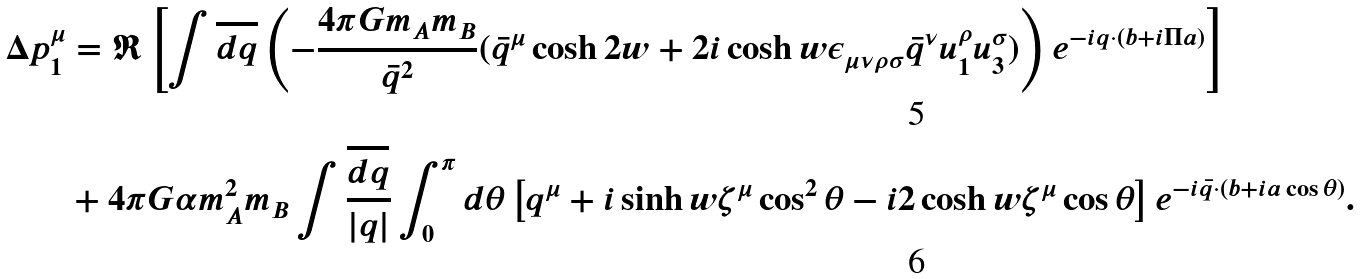<formula> <loc_0><loc_0><loc_500><loc_500>\Delta p ^ { \mu } _ { 1 } & = \Re \left [ \int \overline { d q } \left ( - \frac { 4 \pi G m _ { A } m _ { B } } { \bar { q } ^ { 2 } } ( \bar { q } ^ { \mu } \cosh 2 w + 2 i \cosh w \epsilon _ { \mu \nu \rho \sigma } \bar { q } ^ { \nu } u _ { 1 } ^ { \rho } u _ { 3 } ^ { \sigma } ) \right ) e ^ { - i q \cdot ( b + i \Pi a ) } \right ] \\ & + 4 \pi G \alpha m _ { A } ^ { 2 } m _ { B } \int \frac { \overline { d q } } { | q | } \int _ { 0 } ^ { \pi } d \theta \left [ q ^ { \mu } + i \sinh w \zeta ^ { \mu } \cos ^ { 2 } \theta - i 2 \cosh w \zeta ^ { \mu } \cos \theta \right ] e ^ { - i \bar { q } \cdot ( b + i a \cos \theta ) } .</formula> 